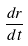Convert formula to latex. <formula><loc_0><loc_0><loc_500><loc_500>\frac { d r } { d t }</formula> 